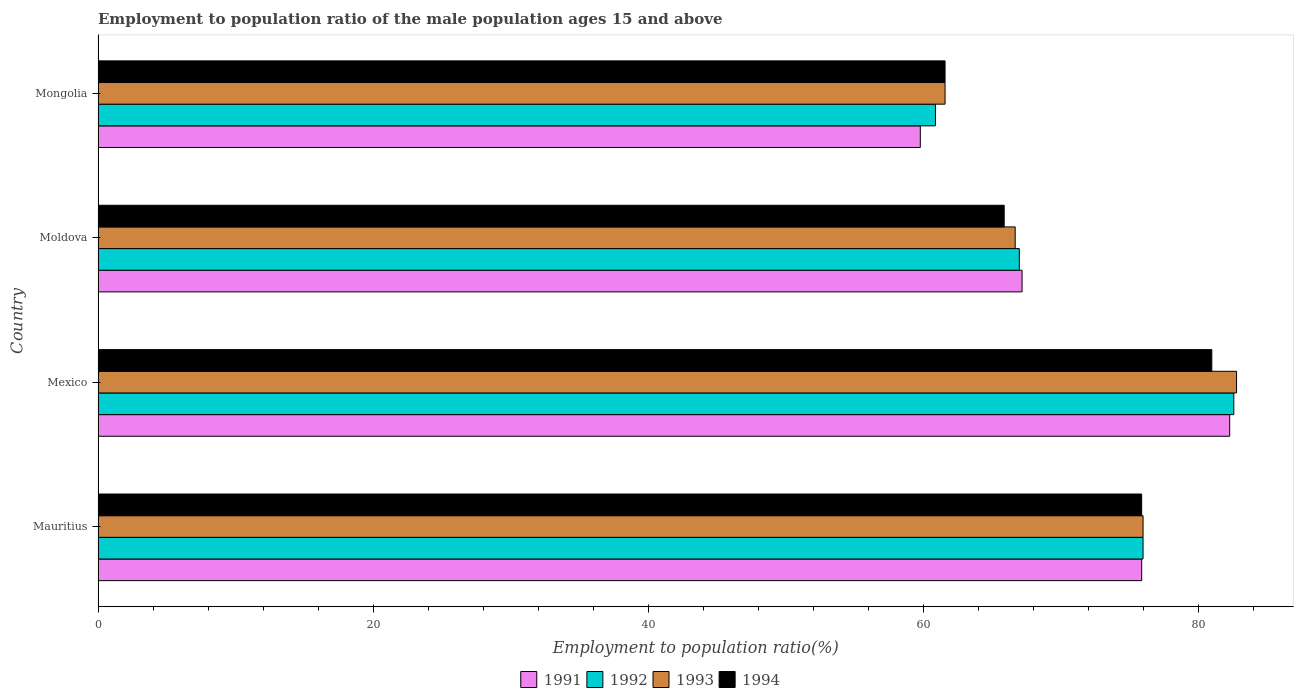How many bars are there on the 1st tick from the bottom?
Offer a terse response. 4. What is the label of the 2nd group of bars from the top?
Keep it short and to the point. Moldova. What is the employment to population ratio in 1991 in Mexico?
Offer a very short reply. 82.3. Across all countries, what is the maximum employment to population ratio in 1993?
Provide a succinct answer. 82.8. Across all countries, what is the minimum employment to population ratio in 1993?
Your response must be concise. 61.6. In which country was the employment to population ratio in 1992 minimum?
Keep it short and to the point. Mongolia. What is the total employment to population ratio in 1991 in the graph?
Your answer should be compact. 285.2. What is the difference between the employment to population ratio in 1993 in Mexico and that in Moldova?
Offer a terse response. 16.1. What is the difference between the employment to population ratio in 1993 in Mongolia and the employment to population ratio in 1994 in Mexico?
Provide a short and direct response. -19.4. What is the average employment to population ratio in 1994 per country?
Your response must be concise. 71.1. What is the difference between the employment to population ratio in 1994 and employment to population ratio in 1992 in Moldova?
Make the answer very short. -1.1. What is the ratio of the employment to population ratio in 1991 in Mexico to that in Moldova?
Offer a terse response. 1.22. Is the employment to population ratio in 1993 in Mauritius less than that in Moldova?
Ensure brevity in your answer.  No. What is the difference between the highest and the second highest employment to population ratio in 1993?
Your response must be concise. 6.8. What is the difference between the highest and the lowest employment to population ratio in 1993?
Your answer should be very brief. 21.2. In how many countries, is the employment to population ratio in 1992 greater than the average employment to population ratio in 1992 taken over all countries?
Provide a succinct answer. 2. Is it the case that in every country, the sum of the employment to population ratio in 1993 and employment to population ratio in 1991 is greater than the sum of employment to population ratio in 1992 and employment to population ratio in 1994?
Offer a terse response. No. What does the 4th bar from the bottom in Mexico represents?
Give a very brief answer. 1994. Is it the case that in every country, the sum of the employment to population ratio in 1991 and employment to population ratio in 1993 is greater than the employment to population ratio in 1994?
Keep it short and to the point. Yes. Are all the bars in the graph horizontal?
Offer a very short reply. Yes. How many countries are there in the graph?
Ensure brevity in your answer.  4. What is the difference between two consecutive major ticks on the X-axis?
Make the answer very short. 20. Are the values on the major ticks of X-axis written in scientific E-notation?
Provide a short and direct response. No. Does the graph contain grids?
Your answer should be compact. No. How are the legend labels stacked?
Make the answer very short. Horizontal. What is the title of the graph?
Ensure brevity in your answer.  Employment to population ratio of the male population ages 15 and above. What is the Employment to population ratio(%) in 1991 in Mauritius?
Offer a very short reply. 75.9. What is the Employment to population ratio(%) in 1993 in Mauritius?
Your answer should be compact. 76. What is the Employment to population ratio(%) in 1994 in Mauritius?
Offer a terse response. 75.9. What is the Employment to population ratio(%) of 1991 in Mexico?
Keep it short and to the point. 82.3. What is the Employment to population ratio(%) in 1992 in Mexico?
Your response must be concise. 82.6. What is the Employment to population ratio(%) of 1993 in Mexico?
Keep it short and to the point. 82.8. What is the Employment to population ratio(%) of 1994 in Mexico?
Offer a terse response. 81. What is the Employment to population ratio(%) of 1991 in Moldova?
Make the answer very short. 67.2. What is the Employment to population ratio(%) in 1993 in Moldova?
Offer a very short reply. 66.7. What is the Employment to population ratio(%) of 1994 in Moldova?
Your answer should be very brief. 65.9. What is the Employment to population ratio(%) in 1991 in Mongolia?
Your answer should be compact. 59.8. What is the Employment to population ratio(%) of 1992 in Mongolia?
Give a very brief answer. 60.9. What is the Employment to population ratio(%) of 1993 in Mongolia?
Provide a short and direct response. 61.6. What is the Employment to population ratio(%) in 1994 in Mongolia?
Your response must be concise. 61.6. Across all countries, what is the maximum Employment to population ratio(%) in 1991?
Keep it short and to the point. 82.3. Across all countries, what is the maximum Employment to population ratio(%) in 1992?
Make the answer very short. 82.6. Across all countries, what is the maximum Employment to population ratio(%) in 1993?
Your answer should be very brief. 82.8. Across all countries, what is the maximum Employment to population ratio(%) in 1994?
Provide a succinct answer. 81. Across all countries, what is the minimum Employment to population ratio(%) in 1991?
Ensure brevity in your answer.  59.8. Across all countries, what is the minimum Employment to population ratio(%) in 1992?
Give a very brief answer. 60.9. Across all countries, what is the minimum Employment to population ratio(%) of 1993?
Make the answer very short. 61.6. Across all countries, what is the minimum Employment to population ratio(%) in 1994?
Provide a succinct answer. 61.6. What is the total Employment to population ratio(%) of 1991 in the graph?
Make the answer very short. 285.2. What is the total Employment to population ratio(%) in 1992 in the graph?
Provide a short and direct response. 286.5. What is the total Employment to population ratio(%) in 1993 in the graph?
Ensure brevity in your answer.  287.1. What is the total Employment to population ratio(%) of 1994 in the graph?
Provide a succinct answer. 284.4. What is the difference between the Employment to population ratio(%) in 1992 in Mauritius and that in Mexico?
Your answer should be very brief. -6.6. What is the difference between the Employment to population ratio(%) of 1994 in Mauritius and that in Mexico?
Give a very brief answer. -5.1. What is the difference between the Employment to population ratio(%) of 1991 in Mauritius and that in Moldova?
Give a very brief answer. 8.7. What is the difference between the Employment to population ratio(%) in 1993 in Mauritius and that in Moldova?
Give a very brief answer. 9.3. What is the difference between the Employment to population ratio(%) of 1991 in Mauritius and that in Mongolia?
Your response must be concise. 16.1. What is the difference between the Employment to population ratio(%) of 1992 in Mauritius and that in Mongolia?
Keep it short and to the point. 15.1. What is the difference between the Employment to population ratio(%) in 1993 in Mauritius and that in Mongolia?
Provide a short and direct response. 14.4. What is the difference between the Employment to population ratio(%) of 1991 in Mexico and that in Moldova?
Make the answer very short. 15.1. What is the difference between the Employment to population ratio(%) of 1992 in Mexico and that in Moldova?
Offer a terse response. 15.6. What is the difference between the Employment to population ratio(%) of 1993 in Mexico and that in Moldova?
Make the answer very short. 16.1. What is the difference between the Employment to population ratio(%) in 1991 in Mexico and that in Mongolia?
Make the answer very short. 22.5. What is the difference between the Employment to population ratio(%) of 1992 in Mexico and that in Mongolia?
Provide a succinct answer. 21.7. What is the difference between the Employment to population ratio(%) of 1993 in Mexico and that in Mongolia?
Keep it short and to the point. 21.2. What is the difference between the Employment to population ratio(%) in 1991 in Mauritius and the Employment to population ratio(%) in 1992 in Mexico?
Your response must be concise. -6.7. What is the difference between the Employment to population ratio(%) of 1992 in Mauritius and the Employment to population ratio(%) of 1993 in Mexico?
Offer a terse response. -6.8. What is the difference between the Employment to population ratio(%) of 1992 in Mauritius and the Employment to population ratio(%) of 1994 in Mexico?
Make the answer very short. -5. What is the difference between the Employment to population ratio(%) of 1991 in Mauritius and the Employment to population ratio(%) of 1992 in Moldova?
Make the answer very short. 8.9. What is the difference between the Employment to population ratio(%) of 1991 in Mauritius and the Employment to population ratio(%) of 1993 in Moldova?
Ensure brevity in your answer.  9.2. What is the difference between the Employment to population ratio(%) of 1991 in Mauritius and the Employment to population ratio(%) of 1994 in Moldova?
Make the answer very short. 10. What is the difference between the Employment to population ratio(%) in 1993 in Mauritius and the Employment to population ratio(%) in 1994 in Moldova?
Ensure brevity in your answer.  10.1. What is the difference between the Employment to population ratio(%) in 1991 in Mauritius and the Employment to population ratio(%) in 1992 in Mongolia?
Provide a short and direct response. 15. What is the difference between the Employment to population ratio(%) of 1991 in Mauritius and the Employment to population ratio(%) of 1993 in Mongolia?
Your response must be concise. 14.3. What is the difference between the Employment to population ratio(%) in 1991 in Mexico and the Employment to population ratio(%) in 1992 in Moldova?
Offer a terse response. 15.3. What is the difference between the Employment to population ratio(%) in 1991 in Mexico and the Employment to population ratio(%) in 1993 in Moldova?
Offer a terse response. 15.6. What is the difference between the Employment to population ratio(%) in 1991 in Mexico and the Employment to population ratio(%) in 1994 in Moldova?
Offer a very short reply. 16.4. What is the difference between the Employment to population ratio(%) of 1992 in Mexico and the Employment to population ratio(%) of 1994 in Moldova?
Offer a terse response. 16.7. What is the difference between the Employment to population ratio(%) in 1991 in Mexico and the Employment to population ratio(%) in 1992 in Mongolia?
Your answer should be very brief. 21.4. What is the difference between the Employment to population ratio(%) of 1991 in Mexico and the Employment to population ratio(%) of 1993 in Mongolia?
Ensure brevity in your answer.  20.7. What is the difference between the Employment to population ratio(%) of 1991 in Mexico and the Employment to population ratio(%) of 1994 in Mongolia?
Provide a short and direct response. 20.7. What is the difference between the Employment to population ratio(%) in 1992 in Mexico and the Employment to population ratio(%) in 1994 in Mongolia?
Ensure brevity in your answer.  21. What is the difference between the Employment to population ratio(%) in 1993 in Mexico and the Employment to population ratio(%) in 1994 in Mongolia?
Ensure brevity in your answer.  21.2. What is the difference between the Employment to population ratio(%) in 1991 in Moldova and the Employment to population ratio(%) in 1992 in Mongolia?
Make the answer very short. 6.3. What is the difference between the Employment to population ratio(%) in 1991 in Moldova and the Employment to population ratio(%) in 1994 in Mongolia?
Offer a very short reply. 5.6. What is the difference between the Employment to population ratio(%) in 1992 in Moldova and the Employment to population ratio(%) in 1994 in Mongolia?
Provide a short and direct response. 5.4. What is the average Employment to population ratio(%) in 1991 per country?
Offer a very short reply. 71.3. What is the average Employment to population ratio(%) in 1992 per country?
Offer a terse response. 71.62. What is the average Employment to population ratio(%) of 1993 per country?
Provide a short and direct response. 71.78. What is the average Employment to population ratio(%) of 1994 per country?
Ensure brevity in your answer.  71.1. What is the difference between the Employment to population ratio(%) in 1992 and Employment to population ratio(%) in 1994 in Mauritius?
Ensure brevity in your answer.  0.1. What is the difference between the Employment to population ratio(%) in 1991 and Employment to population ratio(%) in 1993 in Mexico?
Your answer should be very brief. -0.5. What is the difference between the Employment to population ratio(%) of 1991 and Employment to population ratio(%) of 1994 in Mexico?
Offer a very short reply. 1.3. What is the difference between the Employment to population ratio(%) in 1992 and Employment to population ratio(%) in 1993 in Mexico?
Give a very brief answer. -0.2. What is the difference between the Employment to population ratio(%) of 1992 and Employment to population ratio(%) of 1994 in Mexico?
Your answer should be compact. 1.6. What is the difference between the Employment to population ratio(%) in 1993 and Employment to population ratio(%) in 1994 in Mexico?
Keep it short and to the point. 1.8. What is the difference between the Employment to population ratio(%) of 1991 and Employment to population ratio(%) of 1992 in Moldova?
Provide a succinct answer. 0.2. What is the difference between the Employment to population ratio(%) of 1991 and Employment to population ratio(%) of 1994 in Moldova?
Your response must be concise. 1.3. What is the difference between the Employment to population ratio(%) of 1992 and Employment to population ratio(%) of 1993 in Moldova?
Your answer should be very brief. 0.3. What is the difference between the Employment to population ratio(%) of 1992 and Employment to population ratio(%) of 1994 in Moldova?
Make the answer very short. 1.1. What is the difference between the Employment to population ratio(%) in 1993 and Employment to population ratio(%) in 1994 in Moldova?
Your response must be concise. 0.8. What is the difference between the Employment to population ratio(%) of 1991 and Employment to population ratio(%) of 1992 in Mongolia?
Your answer should be very brief. -1.1. What is the ratio of the Employment to population ratio(%) in 1991 in Mauritius to that in Mexico?
Offer a terse response. 0.92. What is the ratio of the Employment to population ratio(%) of 1992 in Mauritius to that in Mexico?
Offer a very short reply. 0.92. What is the ratio of the Employment to population ratio(%) in 1993 in Mauritius to that in Mexico?
Your response must be concise. 0.92. What is the ratio of the Employment to population ratio(%) of 1994 in Mauritius to that in Mexico?
Ensure brevity in your answer.  0.94. What is the ratio of the Employment to population ratio(%) in 1991 in Mauritius to that in Moldova?
Offer a very short reply. 1.13. What is the ratio of the Employment to population ratio(%) of 1992 in Mauritius to that in Moldova?
Offer a very short reply. 1.13. What is the ratio of the Employment to population ratio(%) of 1993 in Mauritius to that in Moldova?
Ensure brevity in your answer.  1.14. What is the ratio of the Employment to population ratio(%) in 1994 in Mauritius to that in Moldova?
Offer a very short reply. 1.15. What is the ratio of the Employment to population ratio(%) of 1991 in Mauritius to that in Mongolia?
Make the answer very short. 1.27. What is the ratio of the Employment to population ratio(%) of 1992 in Mauritius to that in Mongolia?
Keep it short and to the point. 1.25. What is the ratio of the Employment to population ratio(%) in 1993 in Mauritius to that in Mongolia?
Make the answer very short. 1.23. What is the ratio of the Employment to population ratio(%) of 1994 in Mauritius to that in Mongolia?
Give a very brief answer. 1.23. What is the ratio of the Employment to population ratio(%) of 1991 in Mexico to that in Moldova?
Your answer should be compact. 1.22. What is the ratio of the Employment to population ratio(%) of 1992 in Mexico to that in Moldova?
Your response must be concise. 1.23. What is the ratio of the Employment to population ratio(%) in 1993 in Mexico to that in Moldova?
Offer a terse response. 1.24. What is the ratio of the Employment to population ratio(%) in 1994 in Mexico to that in Moldova?
Offer a terse response. 1.23. What is the ratio of the Employment to population ratio(%) of 1991 in Mexico to that in Mongolia?
Provide a short and direct response. 1.38. What is the ratio of the Employment to population ratio(%) in 1992 in Mexico to that in Mongolia?
Give a very brief answer. 1.36. What is the ratio of the Employment to population ratio(%) in 1993 in Mexico to that in Mongolia?
Your answer should be compact. 1.34. What is the ratio of the Employment to population ratio(%) in 1994 in Mexico to that in Mongolia?
Offer a terse response. 1.31. What is the ratio of the Employment to population ratio(%) of 1991 in Moldova to that in Mongolia?
Your answer should be very brief. 1.12. What is the ratio of the Employment to population ratio(%) of 1992 in Moldova to that in Mongolia?
Your answer should be compact. 1.1. What is the ratio of the Employment to population ratio(%) in 1993 in Moldova to that in Mongolia?
Ensure brevity in your answer.  1.08. What is the ratio of the Employment to population ratio(%) of 1994 in Moldova to that in Mongolia?
Provide a succinct answer. 1.07. What is the difference between the highest and the second highest Employment to population ratio(%) of 1994?
Your response must be concise. 5.1. What is the difference between the highest and the lowest Employment to population ratio(%) of 1991?
Keep it short and to the point. 22.5. What is the difference between the highest and the lowest Employment to population ratio(%) of 1992?
Your response must be concise. 21.7. What is the difference between the highest and the lowest Employment to population ratio(%) of 1993?
Ensure brevity in your answer.  21.2. What is the difference between the highest and the lowest Employment to population ratio(%) of 1994?
Offer a terse response. 19.4. 